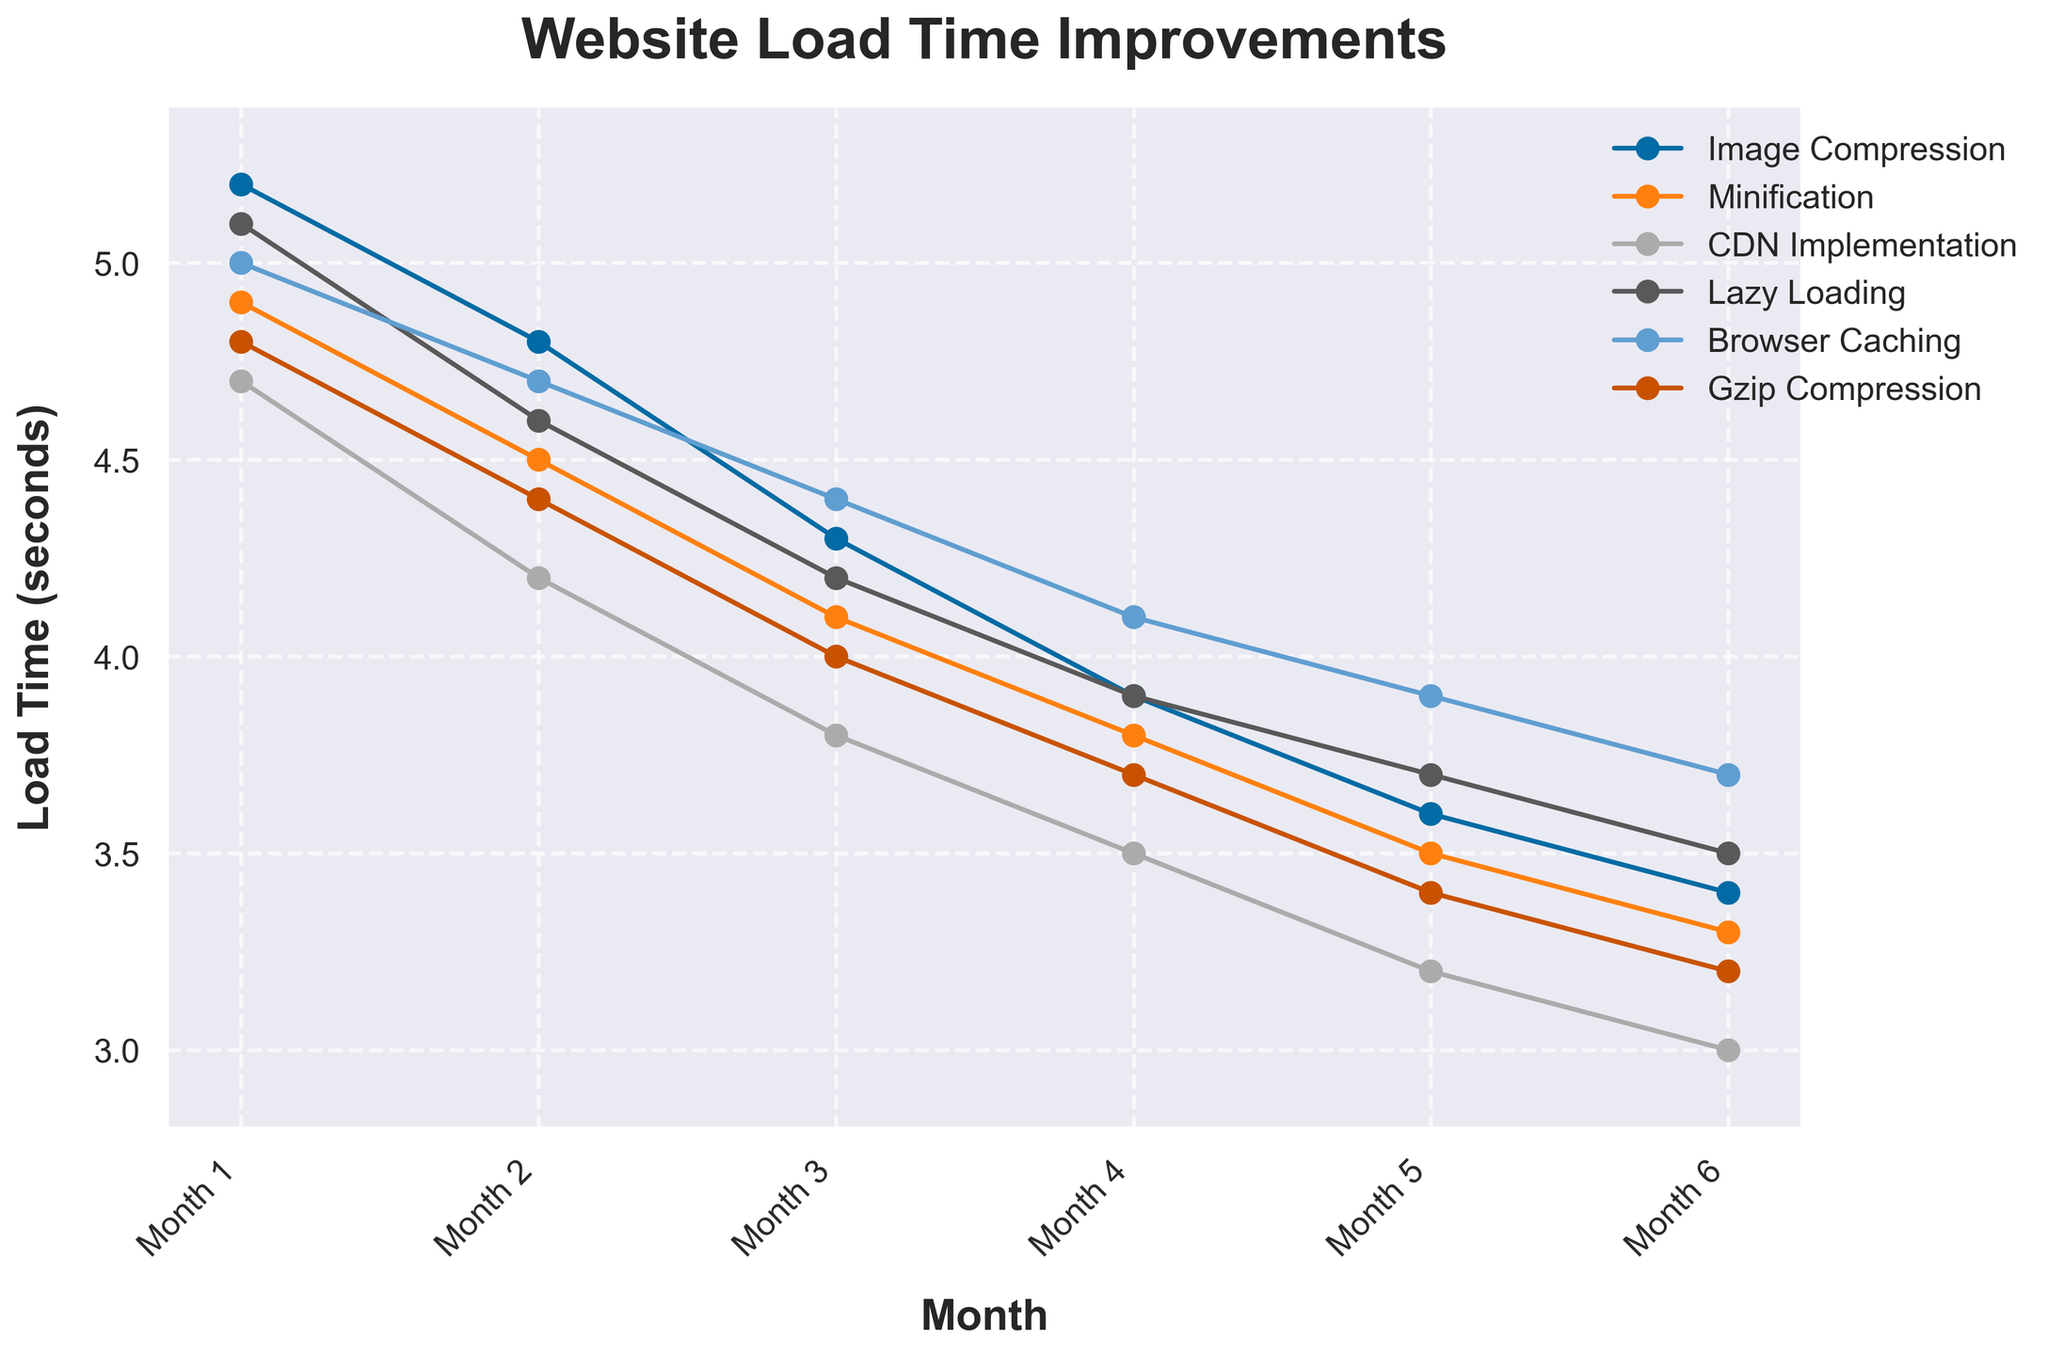What optimization technique consistently showed the lowest load times from Month 1 to Month 6? CDN Implementation consistently showed lower load times compared to the other techniques throughout the 6 months.
Answer: CDN Implementation Between which consecutive months did Image Compression have the largest decrease in load time? Image Compression had the sharpest decrease in load time between Month 1 and Month 2 (5.2 down to 4.8, a decrease of 0.4 seconds).
Answer: Month 1 to Month 2 Which two techniques had the same load time in Month 6? The techniques Lazy Loading and Image Compression both had a load time of 3.5 seconds in Month 6.
Answer: Lazy Loading and Image Compression Which technique showed the least improvement in load time over the 6 months? Browser Caching showed the least improvement in load time, starting at 5.0 seconds and ending at 3.7 seconds, an improvement of 1.3 seconds.
Answer: Browser Caching What was the average load time for Minification across all 6 months? To calculate the average load time for Minification: (4.9 + 4.5 + 4.1 + 3.8 + 3.5 + 3.3) / 6 = 4.02 seconds.
Answer: 4.02 seconds Which technique showed the fastest improvement in load time in the first two months? CDN Implementation showed the fastest initial improvement, decreasing from 4.7 seconds in Month 1 to 4.2 seconds in Month 2, a decrease of 0.5 seconds.
Answer: CDN Implementation Which technique ended with a load time of 3.3 seconds in the final month? Minification ended with a load time of 3.3 seconds in Month 6.
Answer: Minification Visualizing Month 4, which two techniques had equal load times? In Month 4, Image Compression and Lazy Loading both had load times of 3.9 seconds.
Answer: Image Compression and Lazy Loading 